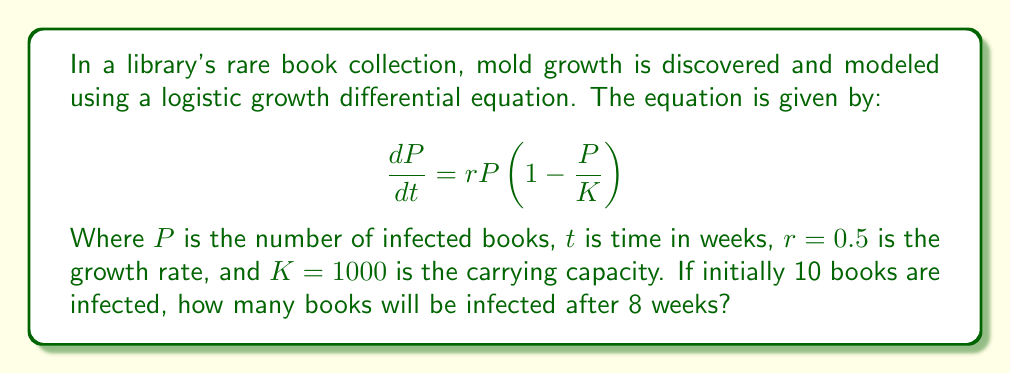Can you answer this question? To solve this problem, we need to use the solution to the logistic growth differential equation:

$$P(t) = \frac{K}{1 + \left(\frac{K}{P_0} - 1\right)e^{-rt}}$$

Where $P_0$ is the initial population.

Given:
- $K = 1000$ (carrying capacity)
- $r = 0.5$ (growth rate)
- $P_0 = 10$ (initial number of infected books)
- $t = 8$ (time in weeks)

Let's substitute these values into the equation:

$$P(8) = \frac{1000}{1 + \left(\frac{1000}{10} - 1\right)e^{-0.5(8)}}$$

$$= \frac{1000}{1 + (99)e^{-4}}$$

$$= \frac{1000}{1 + 99(0.0183)}$$

$$= \frac{1000}{1 + 1.8117}$$

$$= \frac{1000}{2.8117}$$

$$= 355.66$$

Rounding to the nearest whole number (since we can't have a fraction of a book), we get 356 books.
Answer: After 8 weeks, approximately 356 books will be infected by mold. 